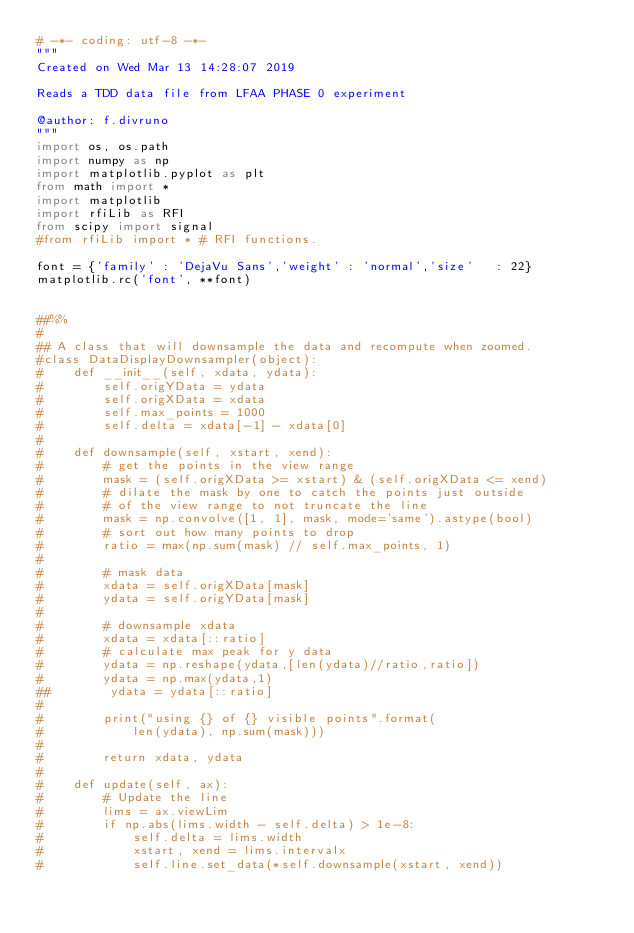<code> <loc_0><loc_0><loc_500><loc_500><_Python_># -*- coding: utf-8 -*-
"""
Created on Wed Mar 13 14:28:07 2019

Reads a TDD data file from LFAA PHASE 0 experiment

@author: f.divruno
"""
import os, os.path
import numpy as np
import matplotlib.pyplot as plt
from math import * 
import matplotlib
import rfiLib as RFI
from scipy import signal 
#from rfiLib import * # RFI functions.

font = {'family' : 'DejaVu Sans','weight' : 'normal','size'   : 22}
matplotlib.rc('font', **font)


##%%
#
## A class that will downsample the data and recompute when zoomed.
#class DataDisplayDownsampler(object):
#    def __init__(self, xdata, ydata):
#        self.origYData = ydata
#        self.origXData = xdata
#        self.max_points = 1000
#        self.delta = xdata[-1] - xdata[0]
#
#    def downsample(self, xstart, xend):
#        # get the points in the view range
#        mask = (self.origXData >= xstart) & (self.origXData <= xend)
#        # dilate the mask by one to catch the points just outside
#        # of the view range to not truncate the line
#        mask = np.convolve([1, 1], mask, mode='same').astype(bool)
#        # sort out how many points to drop
#        ratio = max(np.sum(mask) // self.max_points, 1)
#
#        # mask data
#        xdata = self.origXData[mask]
#        ydata = self.origYData[mask]
#
#        # downsample xdata
#        xdata = xdata[::ratio]
#        # calculate max peak for y data
#        ydata = np.reshape(ydata,[len(ydata)//ratio,ratio])
#        ydata = np.max(ydata,1)
##        ydata = ydata[::ratio]
#
#        print("using {} of {} visible points".format(
#            len(ydata), np.sum(mask)))
#
#        return xdata, ydata
#
#    def update(self, ax):
#        # Update the line
#        lims = ax.viewLim
#        if np.abs(lims.width - self.delta) > 1e-8:
#            self.delta = lims.width
#            xstart, xend = lims.intervalx
#            self.line.set_data(*self.downsample(xstart, xend))</code> 